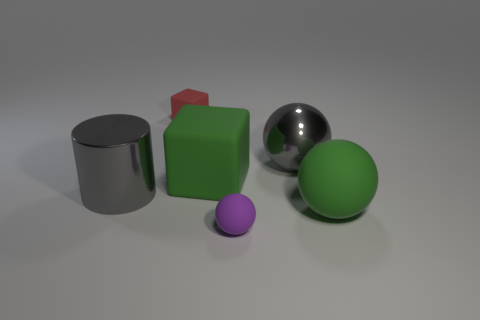Add 4 blue cylinders. How many objects exist? 10 Subtract all large gray shiny spheres. How many spheres are left? 2 Subtract 2 balls. How many balls are left? 1 Subtract all cubes. How many objects are left? 4 Subtract all purple cylinders. Subtract all gray balls. How many cylinders are left? 1 Subtract all blue cylinders. How many green spheres are left? 1 Subtract all tiny matte objects. Subtract all purple objects. How many objects are left? 3 Add 1 gray balls. How many gray balls are left? 2 Add 2 tiny red rubber objects. How many tiny red rubber objects exist? 3 Subtract all green cubes. How many cubes are left? 1 